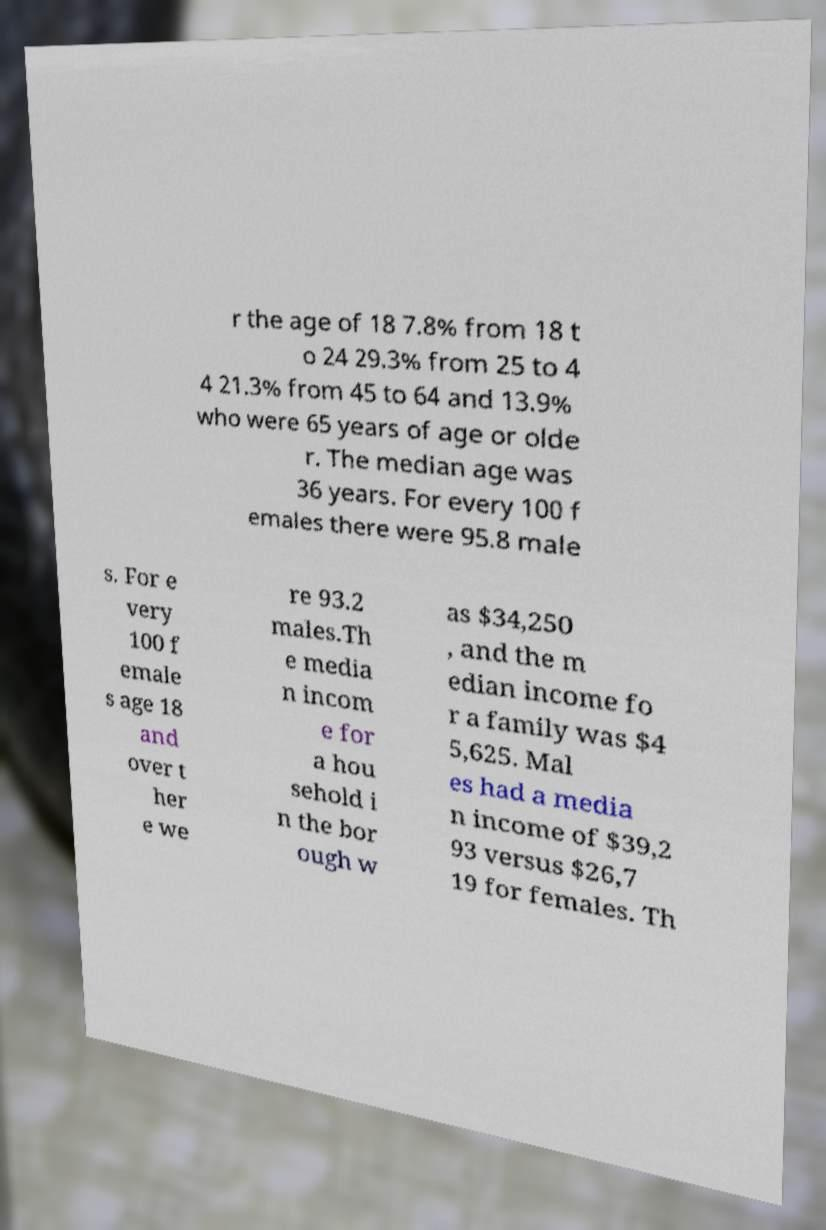There's text embedded in this image that I need extracted. Can you transcribe it verbatim? r the age of 18 7.8% from 18 t o 24 29.3% from 25 to 4 4 21.3% from 45 to 64 and 13.9% who were 65 years of age or olde r. The median age was 36 years. For every 100 f emales there were 95.8 male s. For e very 100 f emale s age 18 and over t her e we re 93.2 males.Th e media n incom e for a hou sehold i n the bor ough w as $34,250 , and the m edian income fo r a family was $4 5,625. Mal es had a media n income of $39,2 93 versus $26,7 19 for females. Th 